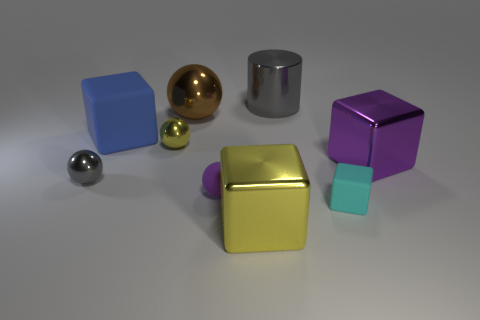Can you tell me about the different materials and shapes shown in this image? The image displays a collection of geometric shapes with various materials. There are several cuboid blocks, two spheres, and a cylinder. Regarding materials, some objects have matte surfaces, such as the purple and blue blocks, while others are reflective, like the golden sphere and the silver cylinder, indicating metallic properties. 